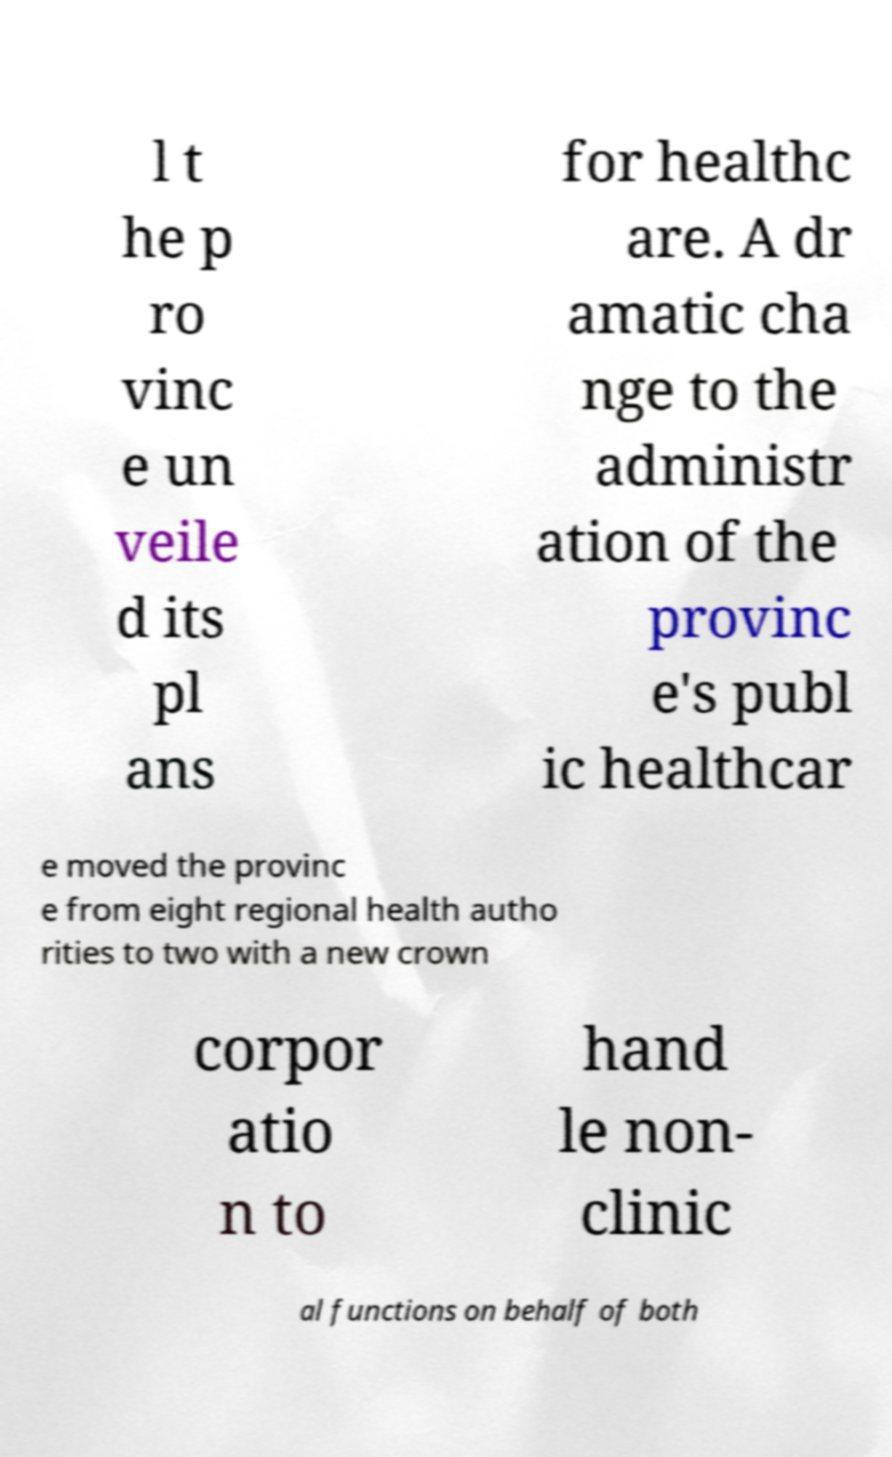Could you extract and type out the text from this image? l t he p ro vinc e un veile d its pl ans for healthc are. A dr amatic cha nge to the administr ation of the provinc e's publ ic healthcar e moved the provinc e from eight regional health autho rities to two with a new crown corpor atio n to hand le non- clinic al functions on behalf of both 